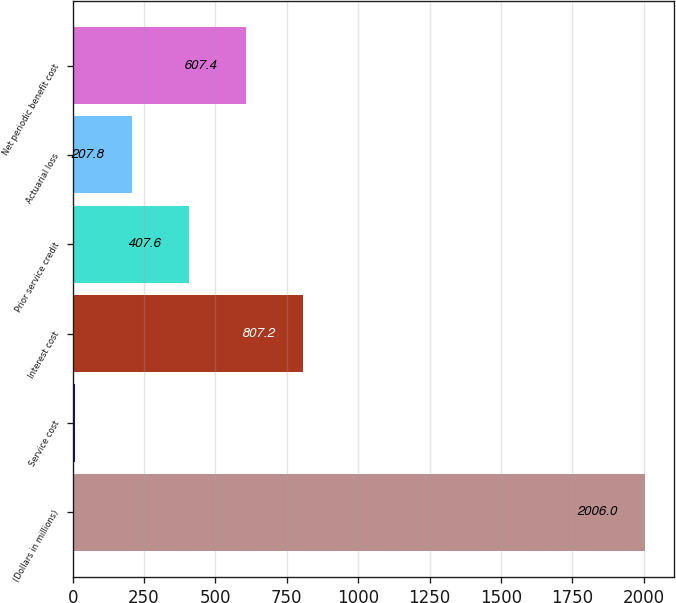<chart> <loc_0><loc_0><loc_500><loc_500><bar_chart><fcel>(Dollars in millions)<fcel>Service cost<fcel>Interest cost<fcel>Prior service credit<fcel>Actuarial loss<fcel>Net periodic benefit cost<nl><fcel>2006<fcel>8<fcel>807.2<fcel>407.6<fcel>207.8<fcel>607.4<nl></chart> 